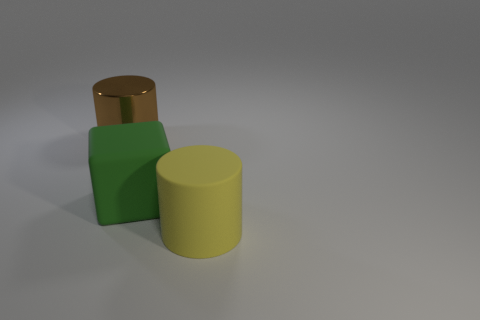Add 1 small gray rubber blocks. How many objects exist? 4 Subtract all blocks. How many objects are left? 2 Add 2 large objects. How many large objects are left? 5 Add 2 big green things. How many big green things exist? 3 Subtract 0 brown spheres. How many objects are left? 3 Subtract all tiny red balls. Subtract all big things. How many objects are left? 0 